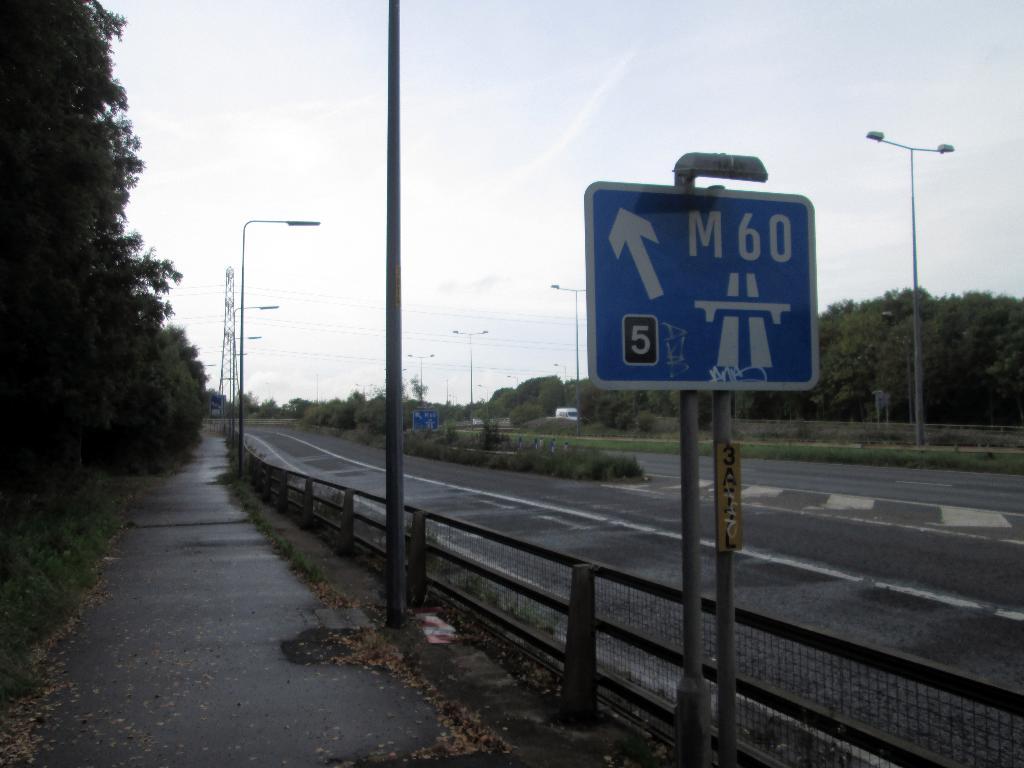What does the number say in black?
Ensure brevity in your answer.  5. What street does the sign say is up ahead?
Your answer should be compact. M60. 